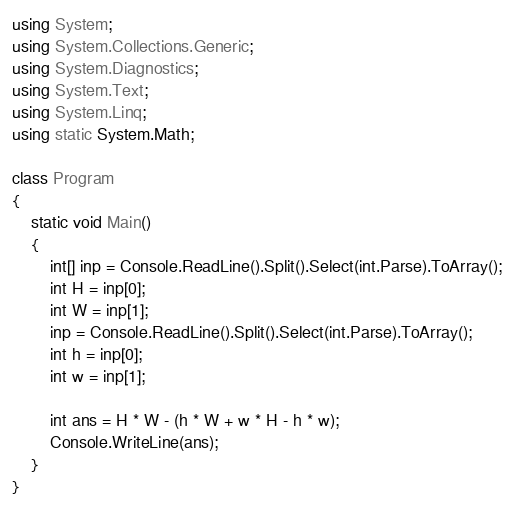Convert code to text. <code><loc_0><loc_0><loc_500><loc_500><_C#_>using System;
using System.Collections.Generic;
using System.Diagnostics;
using System.Text;
using System.Linq;
using static System.Math;

class Program
{
    static void Main()
    {
        int[] inp = Console.ReadLine().Split().Select(int.Parse).ToArray();
        int H = inp[0];
        int W = inp[1];
        inp = Console.ReadLine().Split().Select(int.Parse).ToArray();
        int h = inp[0];
        int w = inp[1];

        int ans = H * W - (h * W + w * H - h * w);
        Console.WriteLine(ans);
    }
}</code> 